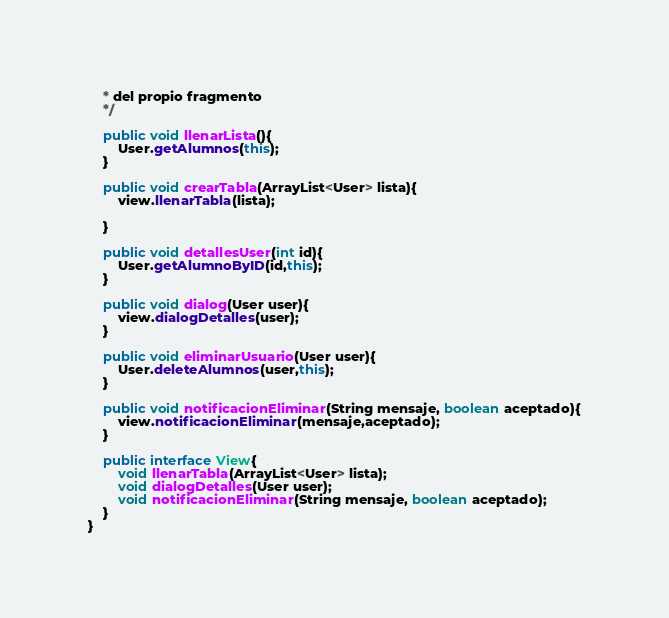Convert code to text. <code><loc_0><loc_0><loc_500><loc_500><_Java_>    * del propio fragmento
    */

    public void llenarLista(){
        User.getAlumnos(this);
    }

    public void crearTabla(ArrayList<User> lista){
        view.llenarTabla(lista);

    }

    public void detallesUser(int id){
        User.getAlumnoByID(id,this);
    }

    public void dialog(User user){
        view.dialogDetalles(user);
    }

    public void eliminarUsuario(User user){
        User.deleteAlumnos(user,this);
    }

    public void notificacionEliminar(String mensaje, boolean aceptado){
        view.notificacionEliminar(mensaje,aceptado);
    }

    public interface View{
        void llenarTabla(ArrayList<User> lista);
        void dialogDetalles(User user);
        void notificacionEliminar(String mensaje, boolean aceptado);
    }
}
</code> 